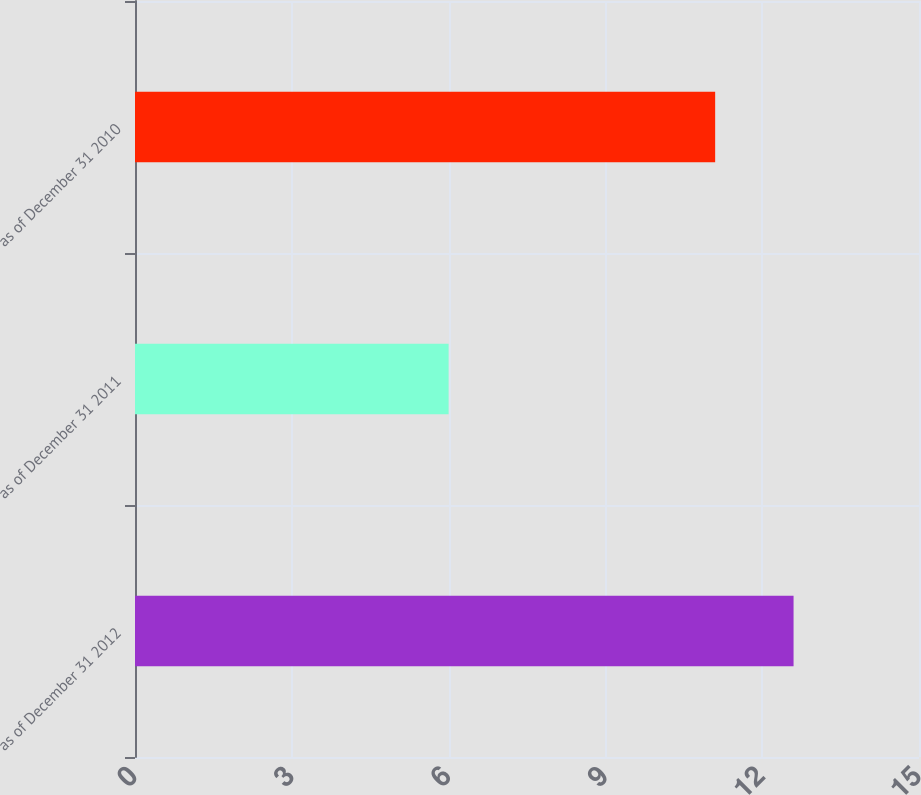Convert chart. <chart><loc_0><loc_0><loc_500><loc_500><bar_chart><fcel>as of December 31 2012<fcel>as of December 31 2011<fcel>as of December 31 2010<nl><fcel>12.6<fcel>6<fcel>11.1<nl></chart> 